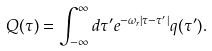Convert formula to latex. <formula><loc_0><loc_0><loc_500><loc_500>Q ( \tau ) = \int _ { - \infty } ^ { \infty } d \tau ^ { \prime } e ^ { - \omega _ { r } | \tau - \tau ^ { \prime } | } q ( \tau ^ { \prime } ) .</formula> 